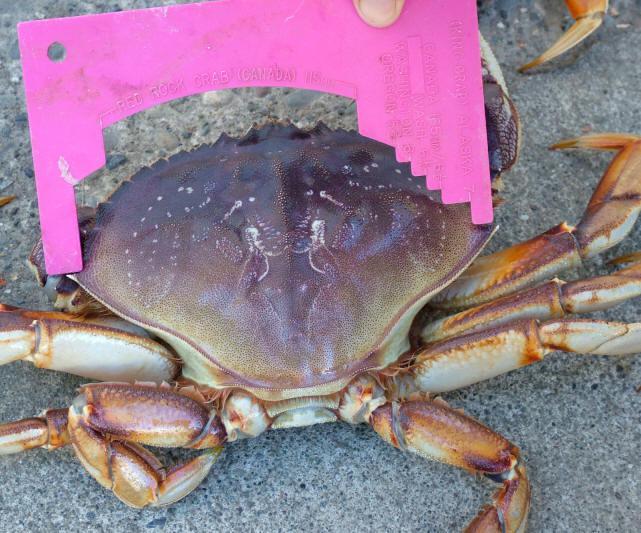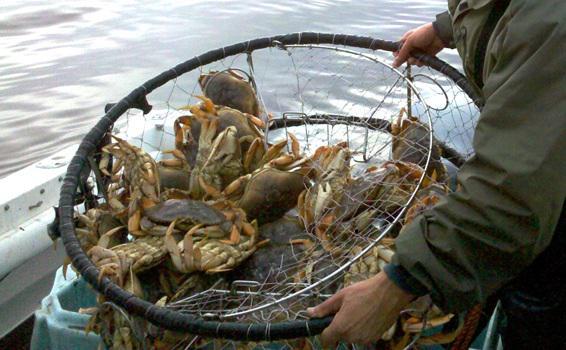The first image is the image on the left, the second image is the image on the right. Given the left and right images, does the statement "In at least one image there is a round crab trap that is holding at least 15 crab while being held by a person in a boat." hold true? Answer yes or no. Yes. The first image is the image on the left, the second image is the image on the right. For the images shown, is this caption "There are crabs inside a cage." true? Answer yes or no. Yes. 